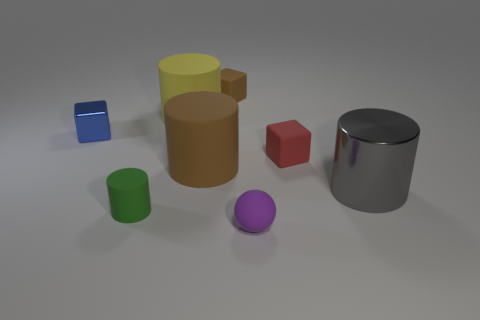What is the shape of the big gray shiny object?
Keep it short and to the point. Cylinder. Are there more tiny green cylinders that are on the left side of the small cylinder than large matte cylinders to the right of the large gray metallic cylinder?
Keep it short and to the point. No. There is a shiny object behind the metallic cylinder; does it have the same shape as the big thing that is behind the large brown object?
Provide a succinct answer. No. How many other things are the same size as the blue object?
Offer a very short reply. 4. What is the size of the blue object?
Make the answer very short. Small. Does the brown thing that is behind the red rubber thing have the same material as the tiny green object?
Offer a terse response. Yes. What is the color of the other tiny object that is the same shape as the yellow thing?
Provide a succinct answer. Green. Do the large cylinder to the right of the red matte cube and the small cylinder have the same color?
Provide a succinct answer. No. There is a gray thing; are there any tiny matte cylinders to the right of it?
Give a very brief answer. No. There is a small cube that is both on the right side of the big brown object and behind the red object; what color is it?
Offer a very short reply. Brown. 